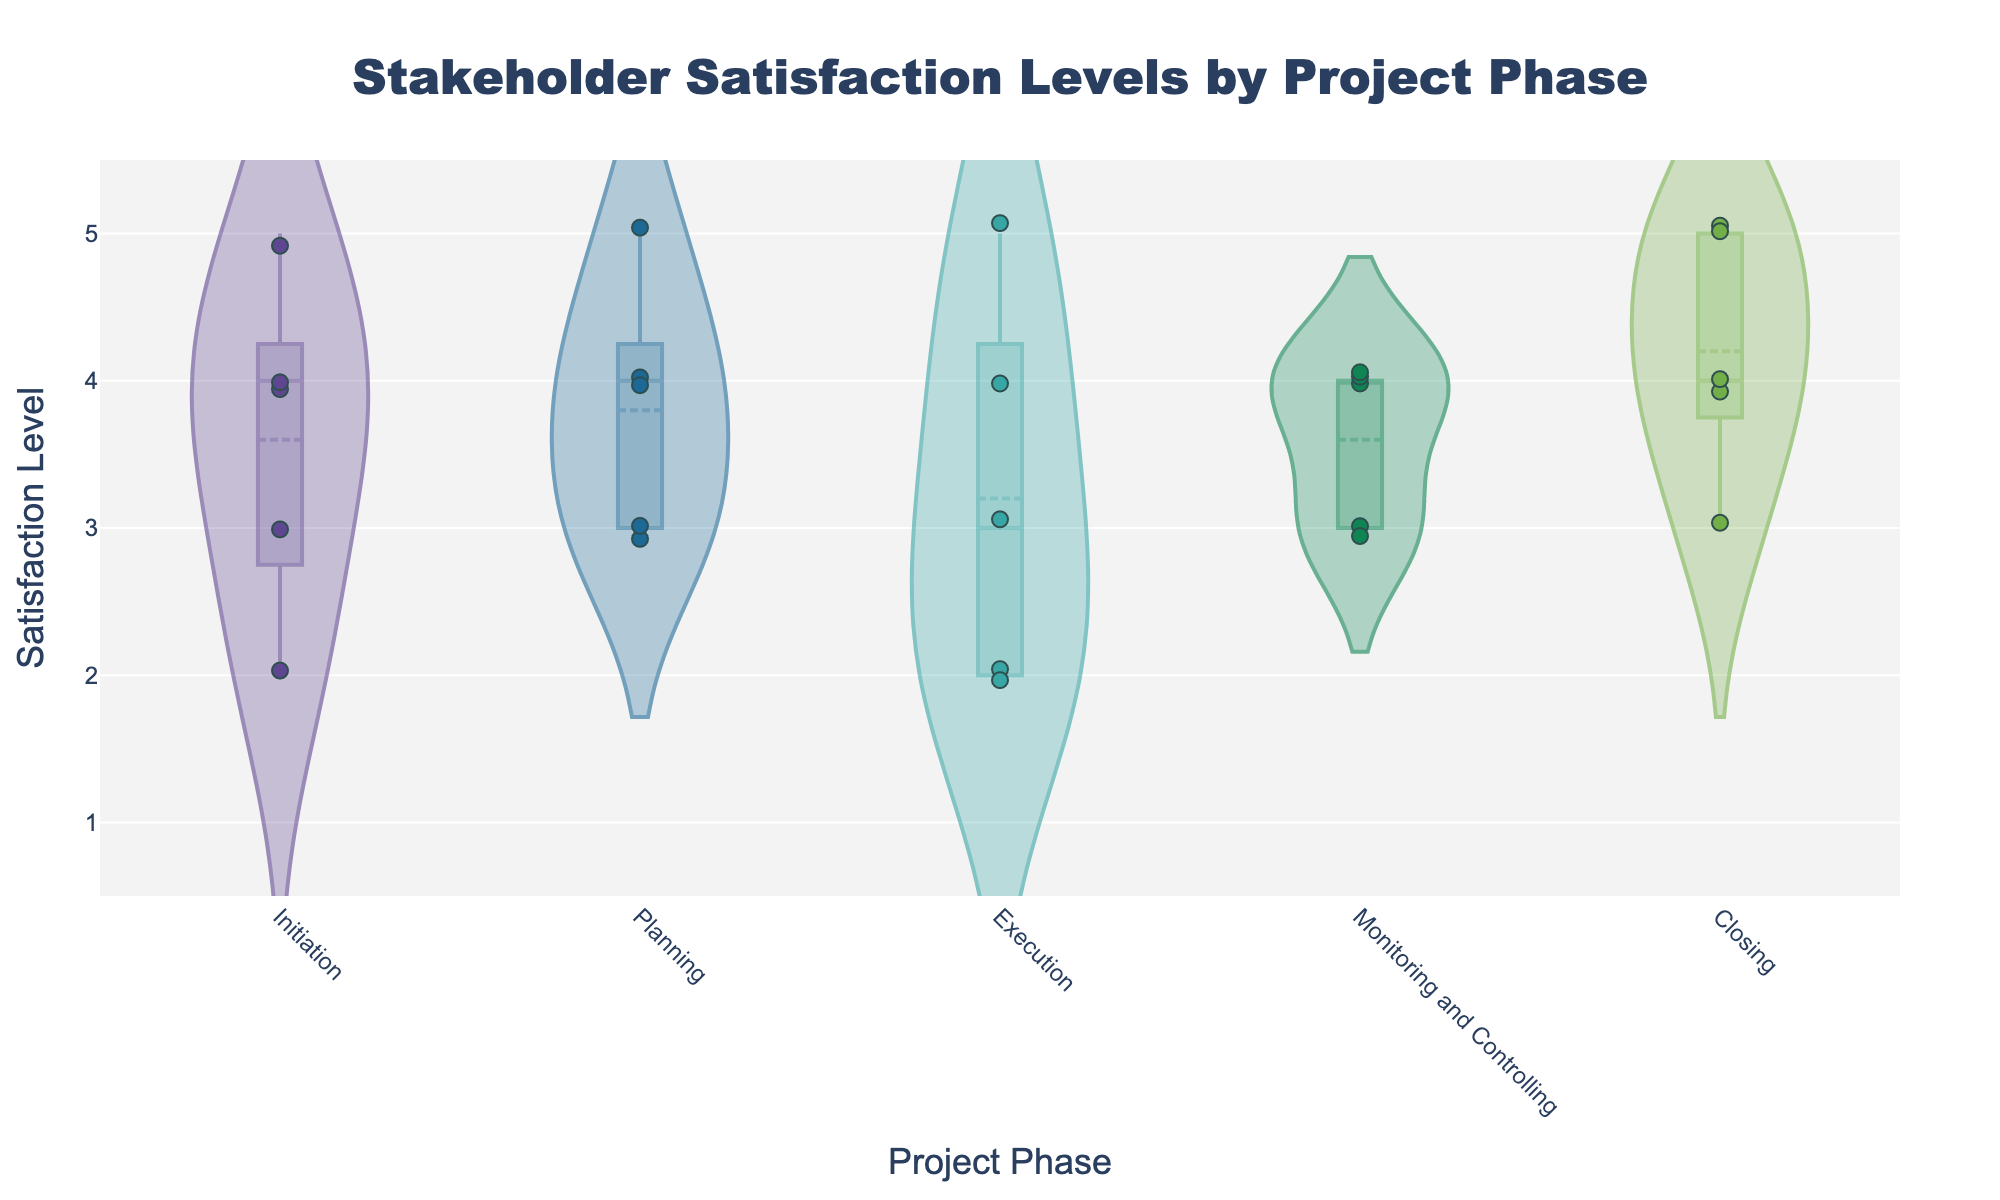What's the title of the figure? The title is typically the most prominently displayed text at the top of the figure. In this case, it is "Stakeholder Satisfaction Levels by Project Phase" as per the code provided.
Answer: Stakeholder Satisfaction Levels by Project Phase What does the y-axis represent? The y-axis typically shows the scale of the dependent variable. In this figure, the y-axis represents "Satisfaction Level" as indicated by the 'yaxis_title' parameter in the code.
Answer: Satisfaction Level How many different project phases are displayed in the figure? The x-axis shows the different phases which are indicated in the data provided: Initiation, Planning, Execution, Monitoring and Controlling, and Closing. There are 5 different project phases total.
Answer: 5 Which project phase has the highest median satisfaction level? Look at the horizontal line inside each violin plot, which represents the median. The median is highest for the "Closing" phase with the line at the highest satisfaction level.
Answer: Closing Compare the variance of satisfaction levels between the Initiation and Execution phases. The variance in a violin plot can be inferred by the width of the plot. The "Execution" phase shows a wider plot, indicating higher variability, compared to "Initiation" which is narrower.
Answer: Execution has higher variance What is the mean satisfaction level for the Planning phase? In a violin plot, the mean is shown by a line or dot on the plot. For "Planning," refer to this mean line which lies around the score of 3-4.
Answer: Around 3.8 Which project phase shows the widest range in satisfaction levels? The range is shown by the length of the violin plot. The "Execution" phase has the widest plot, indicating the widest range in satisfaction levels.
Answer: Execution How many stakeholders rated the initiation phase with a satisfaction level of 4? The jittered points on the graph indicate individual ratings. For the "Initiation" phase, there are two points at the satisfaction level of 4.
Answer: 2 Are there any phases where all stakeholders have the same satisfaction level? Referring to the violin plots and jittered points, you can observe that all phases show variability, indicating different satisfaction levels for all.
Answer: No Is there a general trend in median satisfaction levels from Initiation to Closing? By looking at the horizontal lines that mark the medians, one can see a general trend where satisfaction increases from Initiation to Closing phases.
Answer: Satisfaction generally increases 